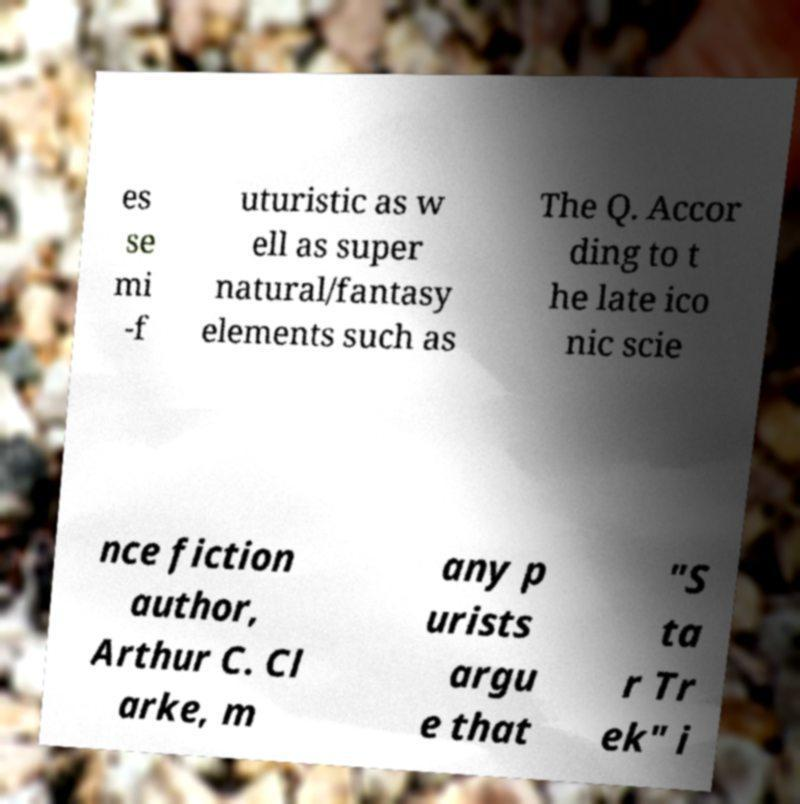For documentation purposes, I need the text within this image transcribed. Could you provide that? es se mi -f uturistic as w ell as super natural/fantasy elements such as The Q. Accor ding to t he late ico nic scie nce fiction author, Arthur C. Cl arke, m any p urists argu e that "S ta r Tr ek" i 